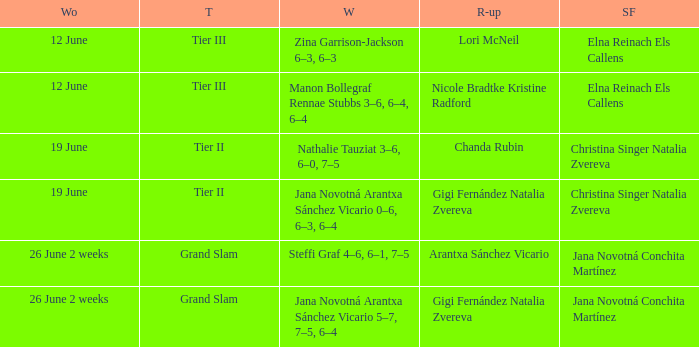Who is the winner in the week listed as 26 June 2 weeks, when the runner-up is Arantxa Sánchez Vicario? Steffi Graf 4–6, 6–1, 7–5. 